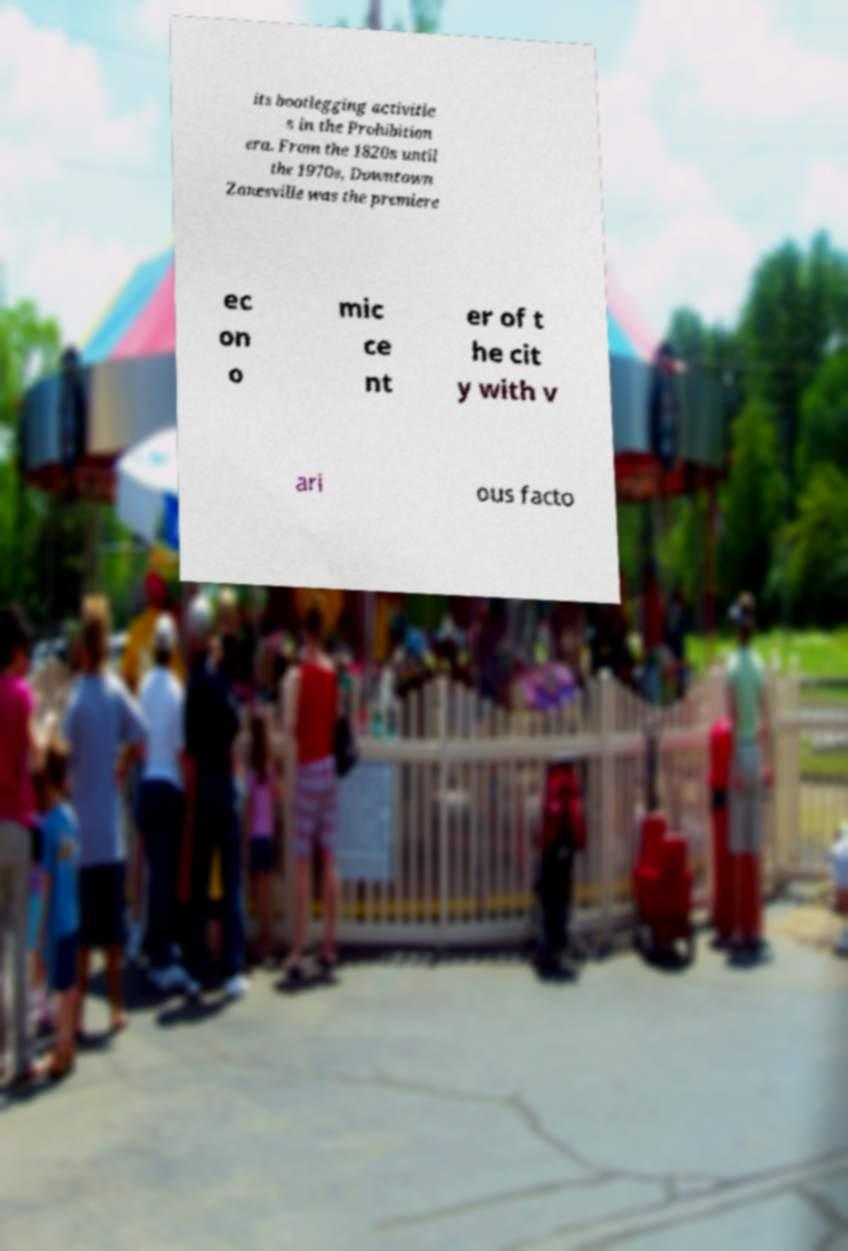Can you read and provide the text displayed in the image?This photo seems to have some interesting text. Can you extract and type it out for me? its bootlegging activitie s in the Prohibition era. From the 1820s until the 1970s, Downtown Zanesville was the premiere ec on o mic ce nt er of t he cit y with v ari ous facto 